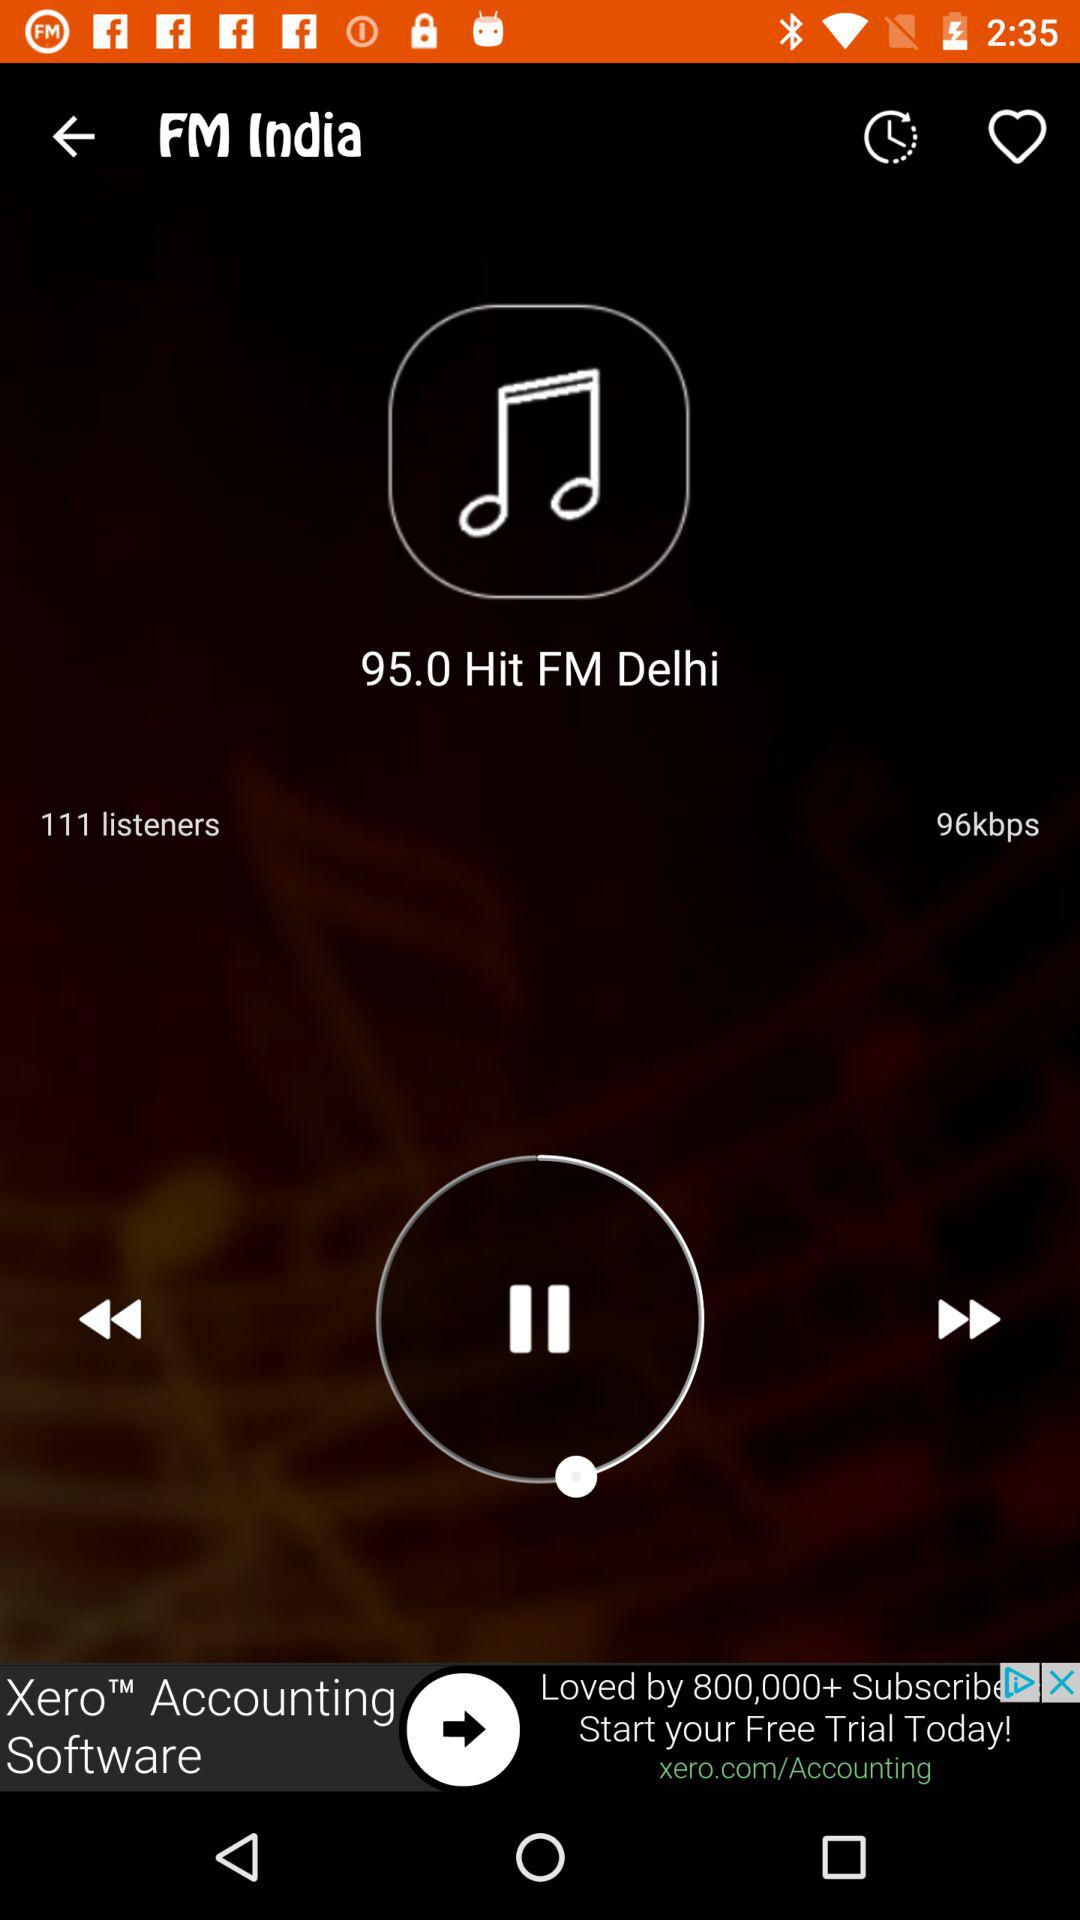What is the streaming speed? The streaming speed is 96 kbps. 